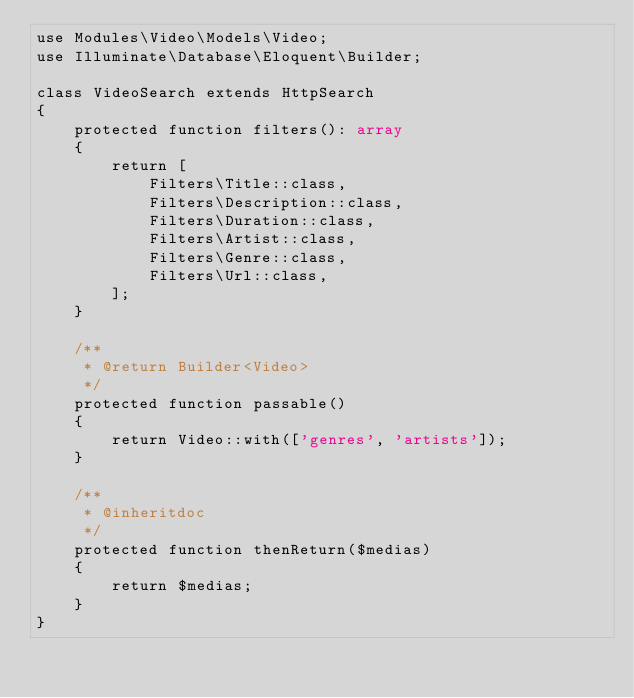<code> <loc_0><loc_0><loc_500><loc_500><_PHP_>use Modules\Video\Models\Video;
use Illuminate\Database\Eloquent\Builder;

class VideoSearch extends HttpSearch
{
    protected function filters(): array
    {
        return [
            Filters\Title::class,
            Filters\Description::class,
            Filters\Duration::class,
            Filters\Artist::class,
            Filters\Genre::class,
            Filters\Url::class,
        ];
    }

    /**
     * @return Builder<Video>
     */
    protected function passable()
    {
        return Video::with(['genres', 'artists']);
    }

    /**
     * @inheritdoc
     */
    protected function thenReturn($medias)
    {
        return $medias;
    }
}
</code> 